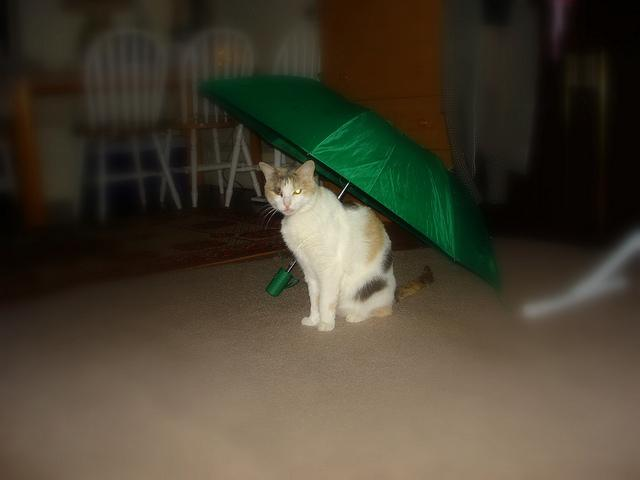What object used to prevent getting wet is nearby the cat in this image?

Choices:
A) chairs
B) carpet
C) umbrella
D) clothing umbrella 